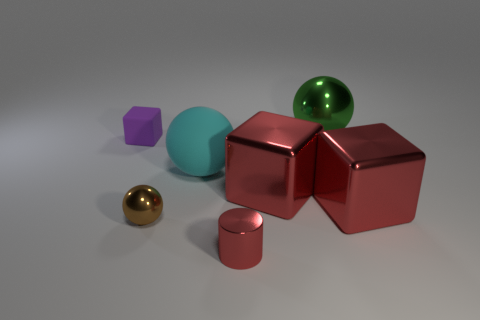Subtract 1 cubes. How many cubes are left? 2 Subtract all big blocks. How many blocks are left? 1 Add 1 big objects. How many objects exist? 8 Subtract all cubes. How many objects are left? 4 Add 4 big rubber things. How many big rubber things are left? 5 Add 6 small red metallic cylinders. How many small red metallic cylinders exist? 7 Subtract 0 purple cylinders. How many objects are left? 7 Subtract all green shiny spheres. Subtract all spheres. How many objects are left? 3 